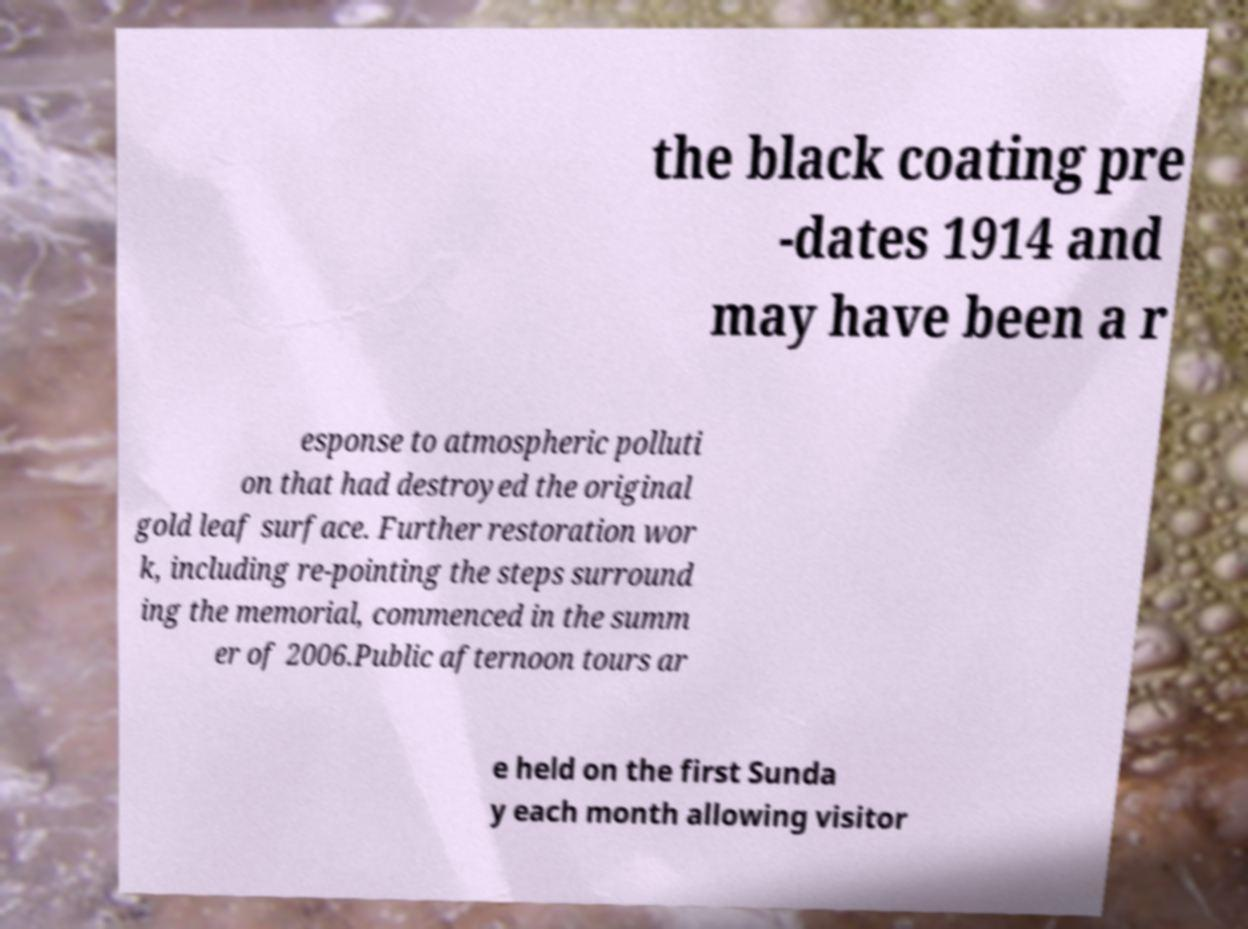Could you assist in decoding the text presented in this image and type it out clearly? the black coating pre -dates 1914 and may have been a r esponse to atmospheric polluti on that had destroyed the original gold leaf surface. Further restoration wor k, including re-pointing the steps surround ing the memorial, commenced in the summ er of 2006.Public afternoon tours ar e held on the first Sunda y each month allowing visitor 